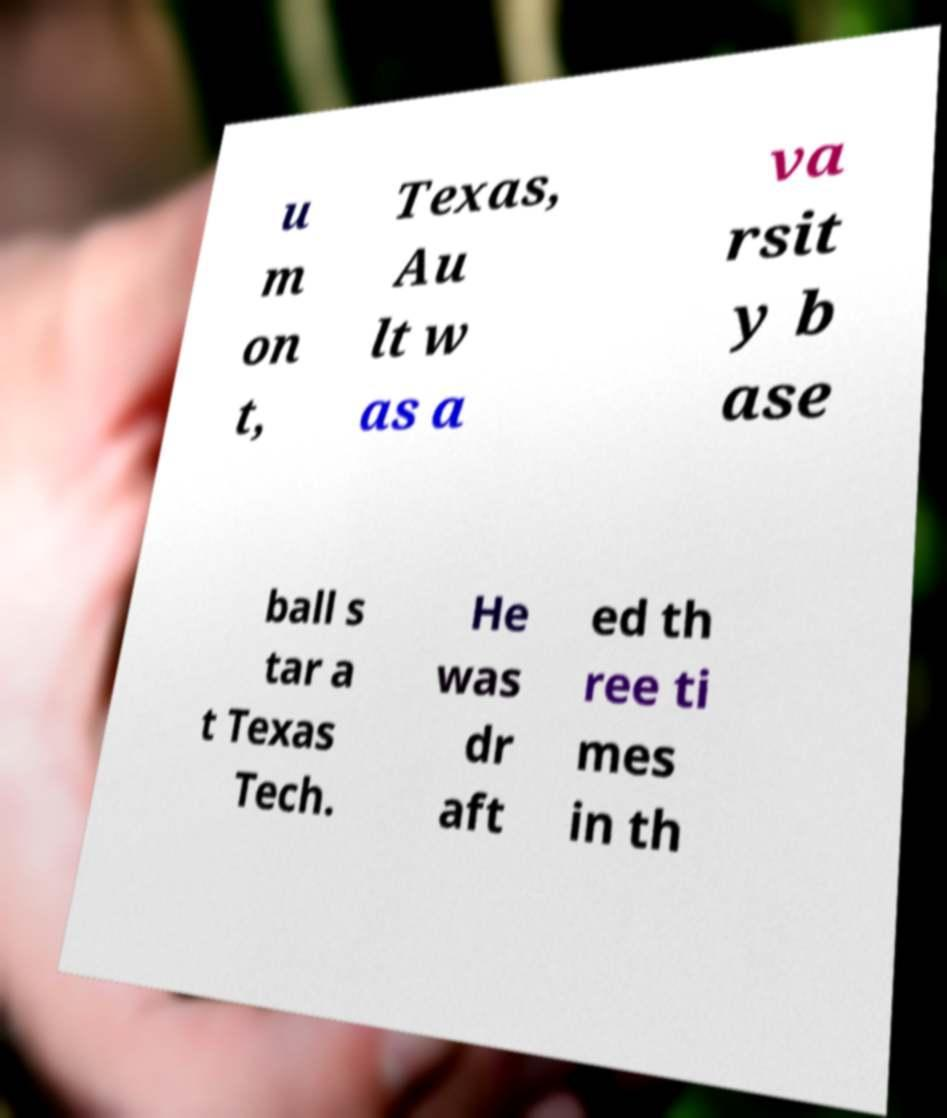For documentation purposes, I need the text within this image transcribed. Could you provide that? u m on t, Texas, Au lt w as a va rsit y b ase ball s tar a t Texas Tech. He was dr aft ed th ree ti mes in th 